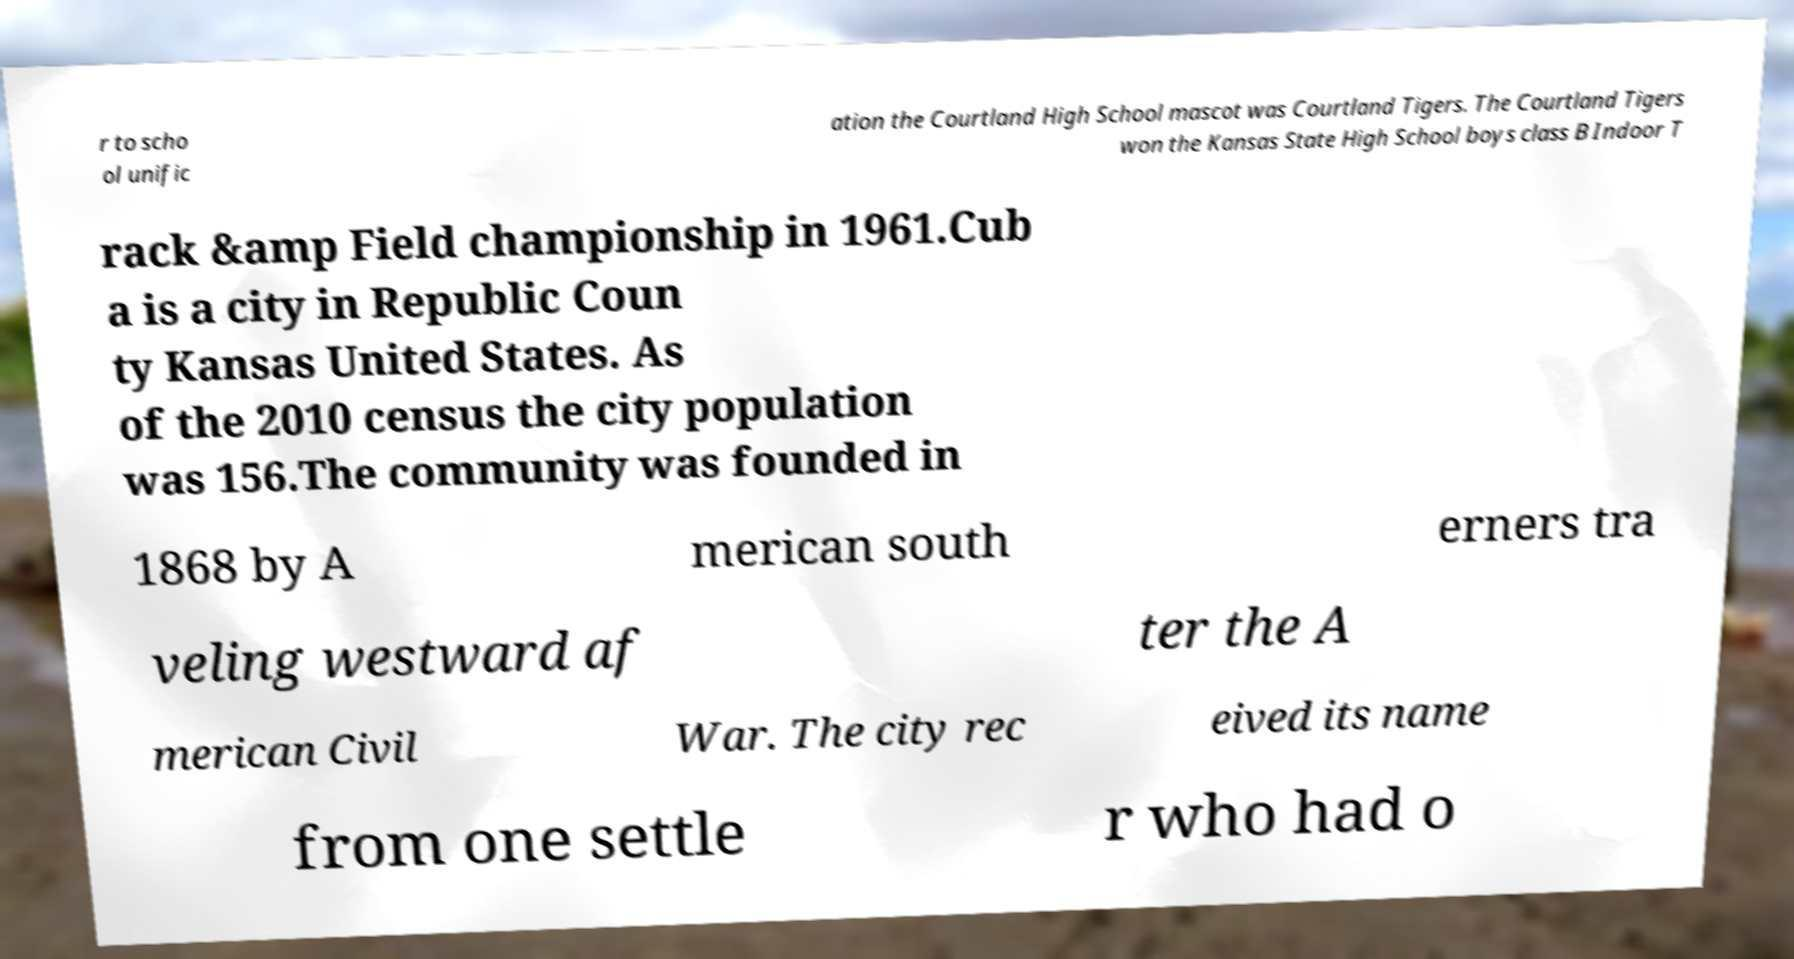Could you extract and type out the text from this image? r to scho ol unific ation the Courtland High School mascot was Courtland Tigers. The Courtland Tigers won the Kansas State High School boys class B Indoor T rack &amp Field championship in 1961.Cub a is a city in Republic Coun ty Kansas United States. As of the 2010 census the city population was 156.The community was founded in 1868 by A merican south erners tra veling westward af ter the A merican Civil War. The city rec eived its name from one settle r who had o 